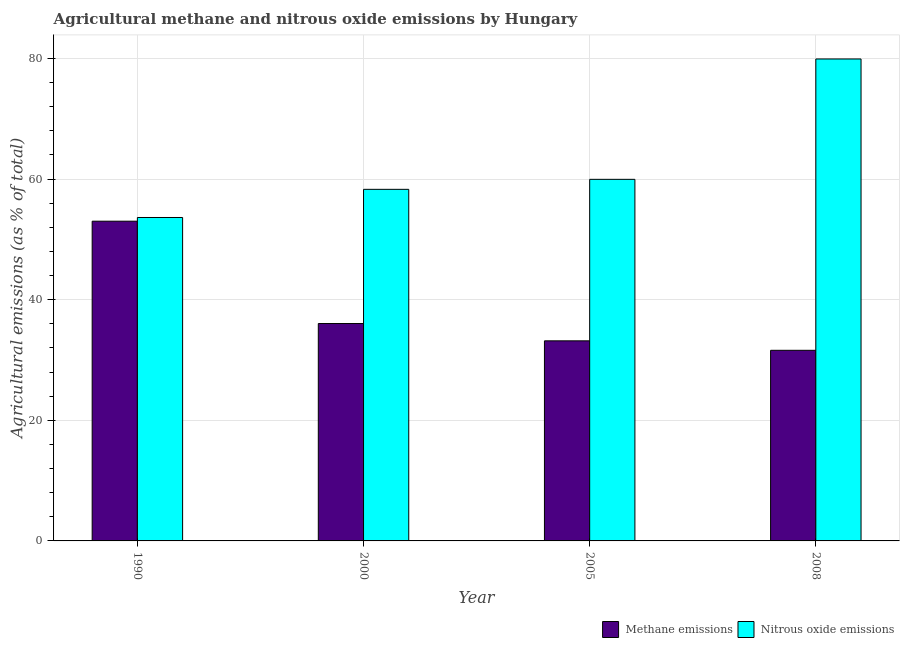How many different coloured bars are there?
Make the answer very short. 2. Are the number of bars on each tick of the X-axis equal?
Your answer should be compact. Yes. How many bars are there on the 3rd tick from the right?
Provide a short and direct response. 2. What is the amount of nitrous oxide emissions in 1990?
Provide a succinct answer. 53.62. Across all years, what is the maximum amount of nitrous oxide emissions?
Your answer should be very brief. 79.9. Across all years, what is the minimum amount of nitrous oxide emissions?
Your response must be concise. 53.62. In which year was the amount of methane emissions maximum?
Provide a succinct answer. 1990. In which year was the amount of methane emissions minimum?
Provide a short and direct response. 2008. What is the total amount of nitrous oxide emissions in the graph?
Your answer should be compact. 251.77. What is the difference between the amount of methane emissions in 2000 and that in 2008?
Provide a succinct answer. 4.44. What is the difference between the amount of methane emissions in 1990 and the amount of nitrous oxide emissions in 2008?
Keep it short and to the point. 21.41. What is the average amount of methane emissions per year?
Your answer should be compact. 38.46. In the year 1990, what is the difference between the amount of nitrous oxide emissions and amount of methane emissions?
Give a very brief answer. 0. What is the ratio of the amount of nitrous oxide emissions in 1990 to that in 2000?
Your answer should be very brief. 0.92. Is the amount of methane emissions in 2000 less than that in 2008?
Your answer should be compact. No. Is the difference between the amount of methane emissions in 2000 and 2005 greater than the difference between the amount of nitrous oxide emissions in 2000 and 2005?
Make the answer very short. No. What is the difference between the highest and the second highest amount of methane emissions?
Your answer should be compact. 16.97. What is the difference between the highest and the lowest amount of nitrous oxide emissions?
Your response must be concise. 26.28. What does the 1st bar from the left in 2000 represents?
Your answer should be compact. Methane emissions. What does the 1st bar from the right in 2000 represents?
Keep it short and to the point. Nitrous oxide emissions. How many bars are there?
Make the answer very short. 8. Are all the bars in the graph horizontal?
Provide a succinct answer. No. How many years are there in the graph?
Ensure brevity in your answer.  4. What is the difference between two consecutive major ticks on the Y-axis?
Offer a terse response. 20. Does the graph contain grids?
Make the answer very short. Yes. How are the legend labels stacked?
Offer a very short reply. Horizontal. What is the title of the graph?
Offer a terse response. Agricultural methane and nitrous oxide emissions by Hungary. Does "Quality of trade" appear as one of the legend labels in the graph?
Ensure brevity in your answer.  No. What is the label or title of the X-axis?
Keep it short and to the point. Year. What is the label or title of the Y-axis?
Provide a short and direct response. Agricultural emissions (as % of total). What is the Agricultural emissions (as % of total) of Methane emissions in 1990?
Give a very brief answer. 53.01. What is the Agricultural emissions (as % of total) in Nitrous oxide emissions in 1990?
Your answer should be compact. 53.62. What is the Agricultural emissions (as % of total) of Methane emissions in 2000?
Keep it short and to the point. 36.04. What is the Agricultural emissions (as % of total) in Nitrous oxide emissions in 2000?
Provide a short and direct response. 58.29. What is the Agricultural emissions (as % of total) of Methane emissions in 2005?
Make the answer very short. 33.17. What is the Agricultural emissions (as % of total) of Nitrous oxide emissions in 2005?
Offer a terse response. 59.95. What is the Agricultural emissions (as % of total) of Methane emissions in 2008?
Offer a very short reply. 31.6. What is the Agricultural emissions (as % of total) in Nitrous oxide emissions in 2008?
Give a very brief answer. 79.9. Across all years, what is the maximum Agricultural emissions (as % of total) in Methane emissions?
Offer a very short reply. 53.01. Across all years, what is the maximum Agricultural emissions (as % of total) of Nitrous oxide emissions?
Offer a very short reply. 79.9. Across all years, what is the minimum Agricultural emissions (as % of total) of Methane emissions?
Your response must be concise. 31.6. Across all years, what is the minimum Agricultural emissions (as % of total) of Nitrous oxide emissions?
Ensure brevity in your answer.  53.62. What is the total Agricultural emissions (as % of total) of Methane emissions in the graph?
Make the answer very short. 153.83. What is the total Agricultural emissions (as % of total) of Nitrous oxide emissions in the graph?
Offer a terse response. 251.77. What is the difference between the Agricultural emissions (as % of total) in Methane emissions in 1990 and that in 2000?
Ensure brevity in your answer.  16.96. What is the difference between the Agricultural emissions (as % of total) of Nitrous oxide emissions in 1990 and that in 2000?
Give a very brief answer. -4.67. What is the difference between the Agricultural emissions (as % of total) of Methane emissions in 1990 and that in 2005?
Ensure brevity in your answer.  19.84. What is the difference between the Agricultural emissions (as % of total) in Nitrous oxide emissions in 1990 and that in 2005?
Your answer should be compact. -6.33. What is the difference between the Agricultural emissions (as % of total) of Methane emissions in 1990 and that in 2008?
Your answer should be very brief. 21.41. What is the difference between the Agricultural emissions (as % of total) of Nitrous oxide emissions in 1990 and that in 2008?
Provide a short and direct response. -26.28. What is the difference between the Agricultural emissions (as % of total) of Methane emissions in 2000 and that in 2005?
Your answer should be very brief. 2.87. What is the difference between the Agricultural emissions (as % of total) in Nitrous oxide emissions in 2000 and that in 2005?
Keep it short and to the point. -1.66. What is the difference between the Agricultural emissions (as % of total) in Methane emissions in 2000 and that in 2008?
Make the answer very short. 4.44. What is the difference between the Agricultural emissions (as % of total) in Nitrous oxide emissions in 2000 and that in 2008?
Ensure brevity in your answer.  -21.61. What is the difference between the Agricultural emissions (as % of total) in Methane emissions in 2005 and that in 2008?
Offer a very short reply. 1.57. What is the difference between the Agricultural emissions (as % of total) in Nitrous oxide emissions in 2005 and that in 2008?
Give a very brief answer. -19.96. What is the difference between the Agricultural emissions (as % of total) in Methane emissions in 1990 and the Agricultural emissions (as % of total) in Nitrous oxide emissions in 2000?
Make the answer very short. -5.28. What is the difference between the Agricultural emissions (as % of total) in Methane emissions in 1990 and the Agricultural emissions (as % of total) in Nitrous oxide emissions in 2005?
Keep it short and to the point. -6.94. What is the difference between the Agricultural emissions (as % of total) of Methane emissions in 1990 and the Agricultural emissions (as % of total) of Nitrous oxide emissions in 2008?
Your answer should be very brief. -26.9. What is the difference between the Agricultural emissions (as % of total) of Methane emissions in 2000 and the Agricultural emissions (as % of total) of Nitrous oxide emissions in 2005?
Your answer should be very brief. -23.91. What is the difference between the Agricultural emissions (as % of total) in Methane emissions in 2000 and the Agricultural emissions (as % of total) in Nitrous oxide emissions in 2008?
Your answer should be very brief. -43.86. What is the difference between the Agricultural emissions (as % of total) in Methane emissions in 2005 and the Agricultural emissions (as % of total) in Nitrous oxide emissions in 2008?
Offer a terse response. -46.73. What is the average Agricultural emissions (as % of total) of Methane emissions per year?
Provide a succinct answer. 38.46. What is the average Agricultural emissions (as % of total) in Nitrous oxide emissions per year?
Ensure brevity in your answer.  62.94. In the year 1990, what is the difference between the Agricultural emissions (as % of total) of Methane emissions and Agricultural emissions (as % of total) of Nitrous oxide emissions?
Your answer should be very brief. -0.61. In the year 2000, what is the difference between the Agricultural emissions (as % of total) in Methane emissions and Agricultural emissions (as % of total) in Nitrous oxide emissions?
Your response must be concise. -22.25. In the year 2005, what is the difference between the Agricultural emissions (as % of total) of Methane emissions and Agricultural emissions (as % of total) of Nitrous oxide emissions?
Your answer should be very brief. -26.78. In the year 2008, what is the difference between the Agricultural emissions (as % of total) in Methane emissions and Agricultural emissions (as % of total) in Nitrous oxide emissions?
Provide a short and direct response. -48.3. What is the ratio of the Agricultural emissions (as % of total) in Methane emissions in 1990 to that in 2000?
Keep it short and to the point. 1.47. What is the ratio of the Agricultural emissions (as % of total) of Nitrous oxide emissions in 1990 to that in 2000?
Provide a succinct answer. 0.92. What is the ratio of the Agricultural emissions (as % of total) of Methane emissions in 1990 to that in 2005?
Your response must be concise. 1.6. What is the ratio of the Agricultural emissions (as % of total) in Nitrous oxide emissions in 1990 to that in 2005?
Offer a terse response. 0.89. What is the ratio of the Agricultural emissions (as % of total) of Methane emissions in 1990 to that in 2008?
Ensure brevity in your answer.  1.68. What is the ratio of the Agricultural emissions (as % of total) in Nitrous oxide emissions in 1990 to that in 2008?
Offer a very short reply. 0.67. What is the ratio of the Agricultural emissions (as % of total) in Methane emissions in 2000 to that in 2005?
Give a very brief answer. 1.09. What is the ratio of the Agricultural emissions (as % of total) of Nitrous oxide emissions in 2000 to that in 2005?
Offer a very short reply. 0.97. What is the ratio of the Agricultural emissions (as % of total) in Methane emissions in 2000 to that in 2008?
Offer a very short reply. 1.14. What is the ratio of the Agricultural emissions (as % of total) of Nitrous oxide emissions in 2000 to that in 2008?
Offer a terse response. 0.73. What is the ratio of the Agricultural emissions (as % of total) of Methane emissions in 2005 to that in 2008?
Offer a terse response. 1.05. What is the ratio of the Agricultural emissions (as % of total) in Nitrous oxide emissions in 2005 to that in 2008?
Make the answer very short. 0.75. What is the difference between the highest and the second highest Agricultural emissions (as % of total) of Methane emissions?
Offer a very short reply. 16.96. What is the difference between the highest and the second highest Agricultural emissions (as % of total) of Nitrous oxide emissions?
Ensure brevity in your answer.  19.96. What is the difference between the highest and the lowest Agricultural emissions (as % of total) of Methane emissions?
Give a very brief answer. 21.41. What is the difference between the highest and the lowest Agricultural emissions (as % of total) in Nitrous oxide emissions?
Ensure brevity in your answer.  26.28. 